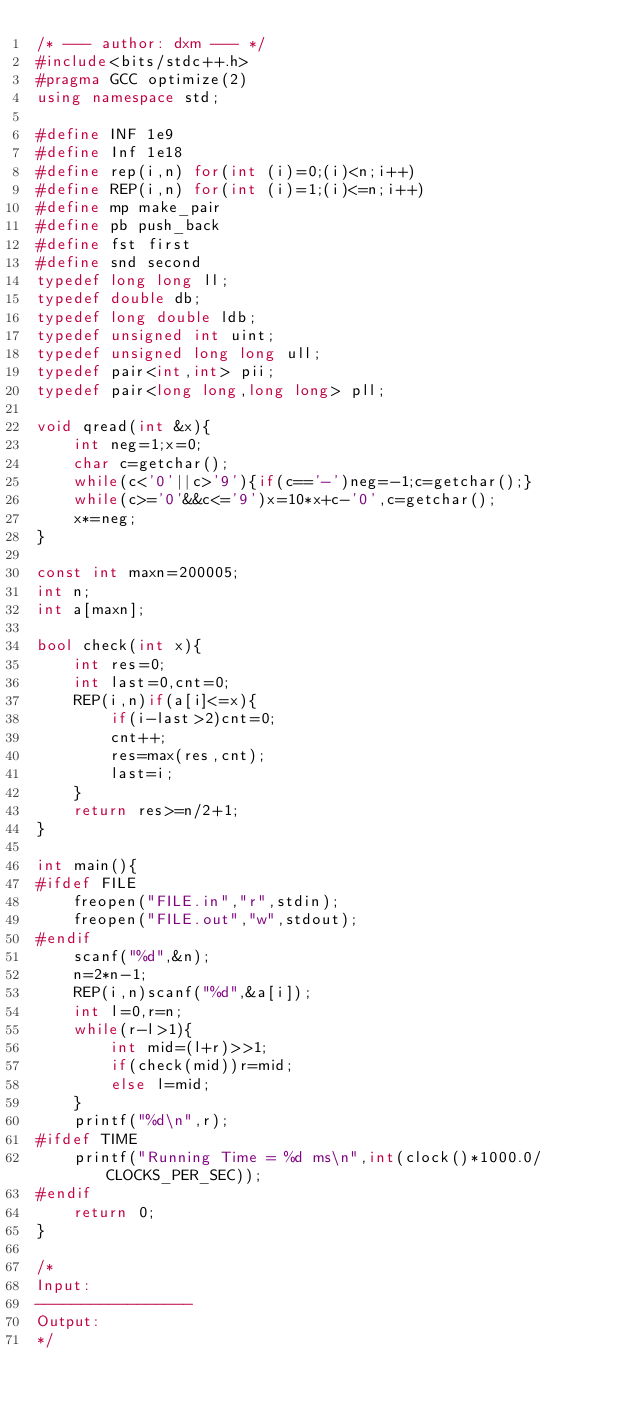Convert code to text. <code><loc_0><loc_0><loc_500><loc_500><_C++_>/* --- author: dxm --- */
#include<bits/stdc++.h>
#pragma GCC optimize(2)
using namespace std;

#define INF 1e9
#define Inf 1e18
#define rep(i,n) for(int (i)=0;(i)<n;i++)
#define REP(i,n) for(int (i)=1;(i)<=n;i++)
#define mp make_pair
#define pb push_back
#define fst first
#define snd second
typedef long long ll;
typedef double db;
typedef long double ldb;
typedef unsigned int uint;
typedef unsigned long long ull;
typedef pair<int,int> pii;
typedef pair<long long,long long> pll;

void qread(int &x){
	int neg=1;x=0;
	char c=getchar(); 
	while(c<'0'||c>'9'){if(c=='-')neg=-1;c=getchar();}
	while(c>='0'&&c<='9')x=10*x+c-'0',c=getchar();
	x*=neg;
}

const int maxn=200005;
int n;
int a[maxn];

bool check(int x){
	int res=0;
	int last=0,cnt=0;
	REP(i,n)if(a[i]<=x){
		if(i-last>2)cnt=0;
		cnt++;
		res=max(res,cnt);
		last=i;
	} 
	return res>=n/2+1;
}

int main(){
#ifdef FILE
	freopen("FILE.in","r",stdin);
	freopen("FILE.out","w",stdout);
#endif
	scanf("%d",&n);
	n=2*n-1;
	REP(i,n)scanf("%d",&a[i]);
	int l=0,r=n;
	while(r-l>1){
		int mid=(l+r)>>1;
		if(check(mid))r=mid;
		else l=mid; 
	}
	printf("%d\n",r);
#ifdef TIME
	printf("Running Time = %d ms\n",int(clock()*1000.0/CLOCKS_PER_SEC));
#endif
	return 0;
}

/*
Input:
-----------------
Output:
*/</code> 